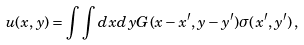<formula> <loc_0><loc_0><loc_500><loc_500>u ( x , y ) = \int \int d x d y G ( x - x ^ { \prime } , y - y ^ { \prime } ) \sigma ( x ^ { \prime } , y ^ { \prime } ) \, ,</formula> 